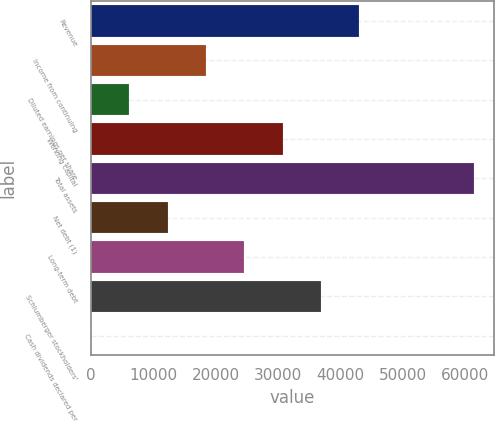<chart> <loc_0><loc_0><loc_500><loc_500><bar_chart><fcel>Revenue<fcel>Income from continuing<fcel>Diluted earnings per share<fcel>Working capital<fcel>Total assets<fcel>Net debt (1)<fcel>Long-term debt<fcel>Schlumberger stockholders'<fcel>Cash dividends declared per<nl><fcel>43083.2<fcel>18464.9<fcel>6155.69<fcel>30774<fcel>61547<fcel>12310.3<fcel>24619.5<fcel>36928.6<fcel>1.1<nl></chart> 